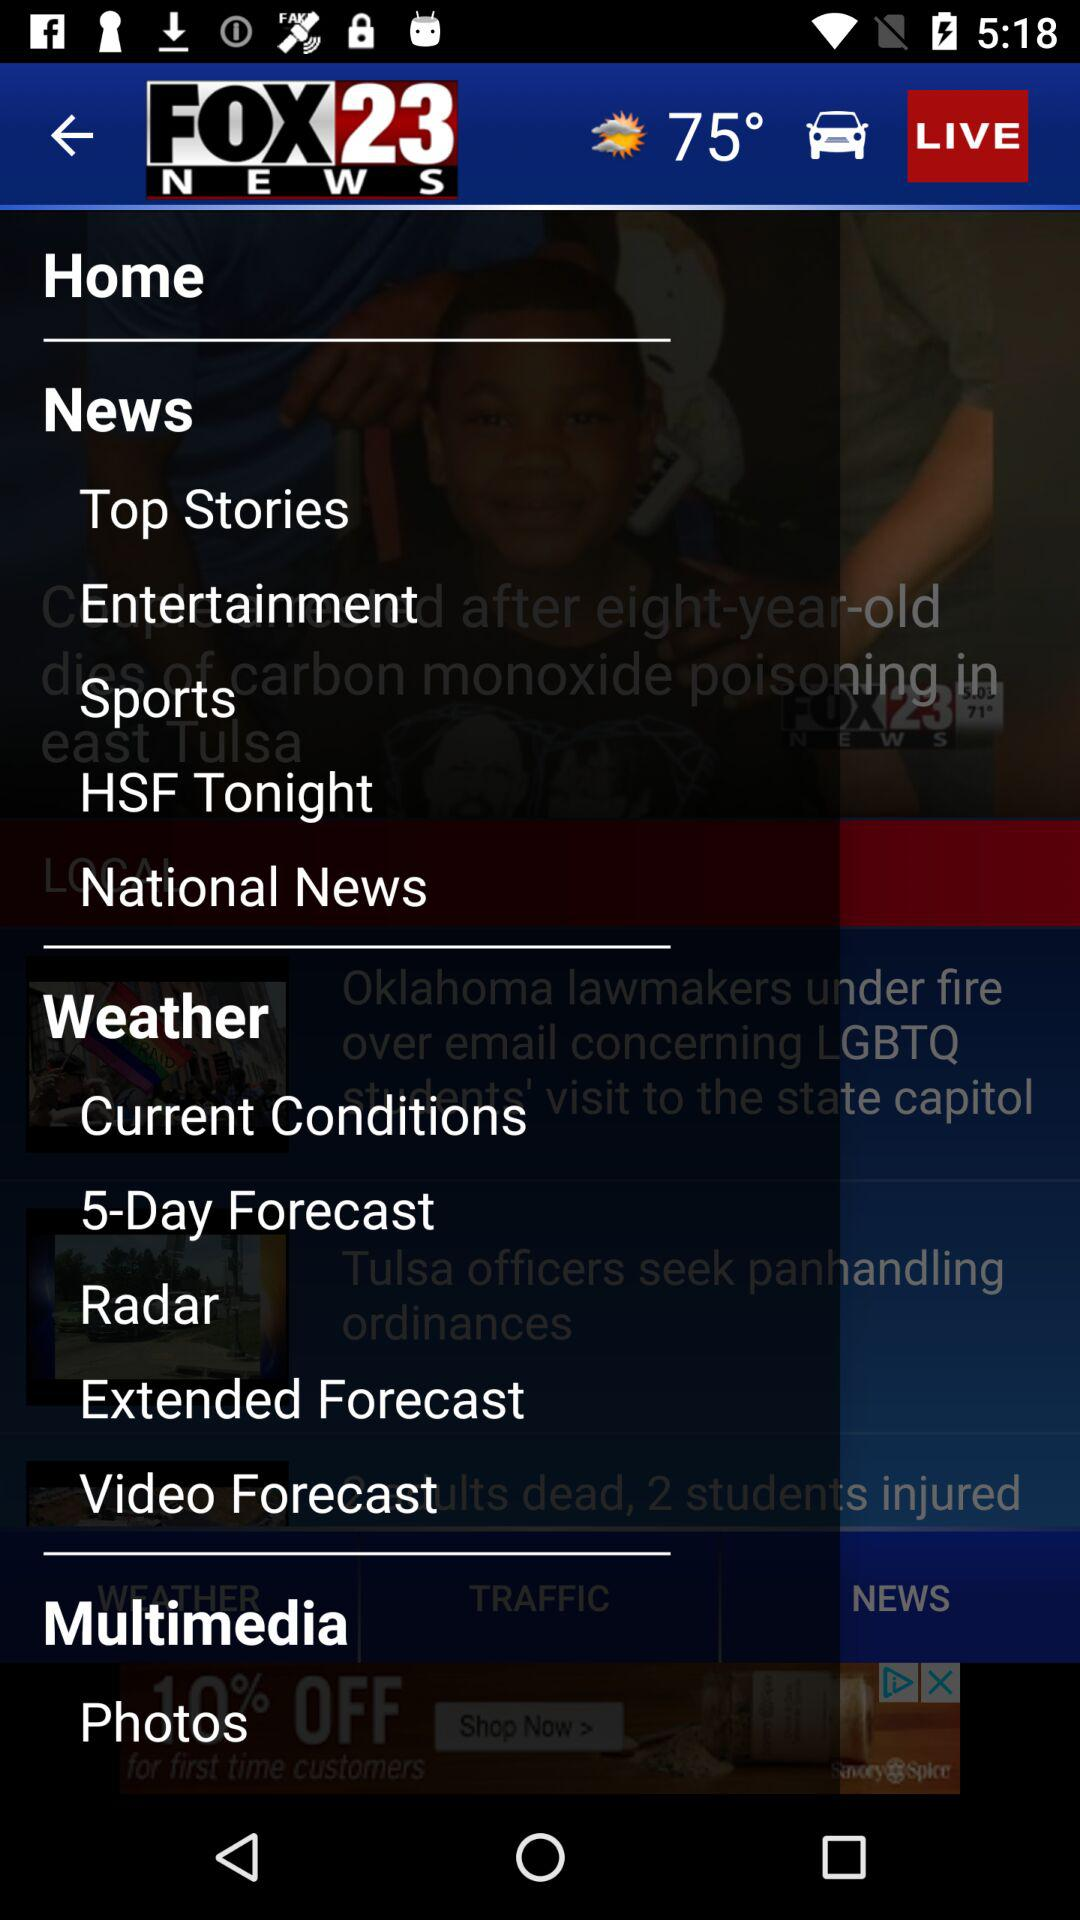What temperature is shown on the screen? The temperature shown on the screen is 75°. 